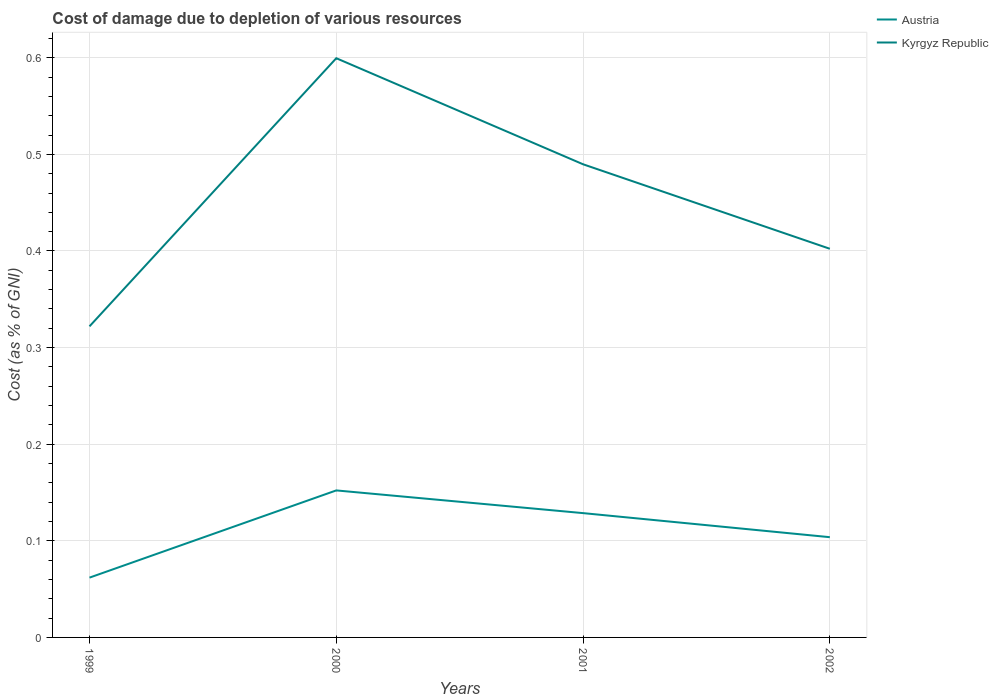Does the line corresponding to Kyrgyz Republic intersect with the line corresponding to Austria?
Your answer should be very brief. No. Is the number of lines equal to the number of legend labels?
Ensure brevity in your answer.  Yes. Across all years, what is the maximum cost of damage caused due to the depletion of various resources in Austria?
Provide a succinct answer. 0.06. What is the total cost of damage caused due to the depletion of various resources in Kyrgyz Republic in the graph?
Your answer should be compact. 0.2. What is the difference between the highest and the second highest cost of damage caused due to the depletion of various resources in Austria?
Give a very brief answer. 0.09. Is the cost of damage caused due to the depletion of various resources in Kyrgyz Republic strictly greater than the cost of damage caused due to the depletion of various resources in Austria over the years?
Give a very brief answer. No. What is the difference between two consecutive major ticks on the Y-axis?
Make the answer very short. 0.1. Does the graph contain grids?
Your answer should be compact. Yes. What is the title of the graph?
Offer a very short reply. Cost of damage due to depletion of various resources. What is the label or title of the X-axis?
Give a very brief answer. Years. What is the label or title of the Y-axis?
Your answer should be compact. Cost (as % of GNI). What is the Cost (as % of GNI) in Austria in 1999?
Provide a succinct answer. 0.06. What is the Cost (as % of GNI) in Kyrgyz Republic in 1999?
Your answer should be very brief. 0.32. What is the Cost (as % of GNI) of Austria in 2000?
Make the answer very short. 0.15. What is the Cost (as % of GNI) in Kyrgyz Republic in 2000?
Ensure brevity in your answer.  0.6. What is the Cost (as % of GNI) of Austria in 2001?
Provide a short and direct response. 0.13. What is the Cost (as % of GNI) of Kyrgyz Republic in 2001?
Make the answer very short. 0.49. What is the Cost (as % of GNI) in Austria in 2002?
Offer a very short reply. 0.1. What is the Cost (as % of GNI) of Kyrgyz Republic in 2002?
Keep it short and to the point. 0.4. Across all years, what is the maximum Cost (as % of GNI) of Austria?
Provide a short and direct response. 0.15. Across all years, what is the maximum Cost (as % of GNI) in Kyrgyz Republic?
Offer a terse response. 0.6. Across all years, what is the minimum Cost (as % of GNI) in Austria?
Offer a terse response. 0.06. Across all years, what is the minimum Cost (as % of GNI) in Kyrgyz Republic?
Your answer should be very brief. 0.32. What is the total Cost (as % of GNI) of Austria in the graph?
Your answer should be very brief. 0.45. What is the total Cost (as % of GNI) in Kyrgyz Republic in the graph?
Give a very brief answer. 1.81. What is the difference between the Cost (as % of GNI) in Austria in 1999 and that in 2000?
Ensure brevity in your answer.  -0.09. What is the difference between the Cost (as % of GNI) of Kyrgyz Republic in 1999 and that in 2000?
Ensure brevity in your answer.  -0.28. What is the difference between the Cost (as % of GNI) in Austria in 1999 and that in 2001?
Give a very brief answer. -0.07. What is the difference between the Cost (as % of GNI) in Kyrgyz Republic in 1999 and that in 2001?
Provide a succinct answer. -0.17. What is the difference between the Cost (as % of GNI) in Austria in 1999 and that in 2002?
Offer a very short reply. -0.04. What is the difference between the Cost (as % of GNI) of Kyrgyz Republic in 1999 and that in 2002?
Your answer should be compact. -0.08. What is the difference between the Cost (as % of GNI) in Austria in 2000 and that in 2001?
Provide a short and direct response. 0.02. What is the difference between the Cost (as % of GNI) in Kyrgyz Republic in 2000 and that in 2001?
Make the answer very short. 0.11. What is the difference between the Cost (as % of GNI) of Austria in 2000 and that in 2002?
Your answer should be very brief. 0.05. What is the difference between the Cost (as % of GNI) of Kyrgyz Republic in 2000 and that in 2002?
Ensure brevity in your answer.  0.2. What is the difference between the Cost (as % of GNI) of Austria in 2001 and that in 2002?
Ensure brevity in your answer.  0.02. What is the difference between the Cost (as % of GNI) of Kyrgyz Republic in 2001 and that in 2002?
Your response must be concise. 0.09. What is the difference between the Cost (as % of GNI) of Austria in 1999 and the Cost (as % of GNI) of Kyrgyz Republic in 2000?
Provide a succinct answer. -0.54. What is the difference between the Cost (as % of GNI) in Austria in 1999 and the Cost (as % of GNI) in Kyrgyz Republic in 2001?
Offer a very short reply. -0.43. What is the difference between the Cost (as % of GNI) in Austria in 1999 and the Cost (as % of GNI) in Kyrgyz Republic in 2002?
Keep it short and to the point. -0.34. What is the difference between the Cost (as % of GNI) in Austria in 2000 and the Cost (as % of GNI) in Kyrgyz Republic in 2001?
Your response must be concise. -0.34. What is the difference between the Cost (as % of GNI) in Austria in 2000 and the Cost (as % of GNI) in Kyrgyz Republic in 2002?
Ensure brevity in your answer.  -0.25. What is the difference between the Cost (as % of GNI) in Austria in 2001 and the Cost (as % of GNI) in Kyrgyz Republic in 2002?
Your response must be concise. -0.27. What is the average Cost (as % of GNI) in Austria per year?
Provide a succinct answer. 0.11. What is the average Cost (as % of GNI) in Kyrgyz Republic per year?
Offer a terse response. 0.45. In the year 1999, what is the difference between the Cost (as % of GNI) of Austria and Cost (as % of GNI) of Kyrgyz Republic?
Provide a succinct answer. -0.26. In the year 2000, what is the difference between the Cost (as % of GNI) in Austria and Cost (as % of GNI) in Kyrgyz Republic?
Ensure brevity in your answer.  -0.45. In the year 2001, what is the difference between the Cost (as % of GNI) of Austria and Cost (as % of GNI) of Kyrgyz Republic?
Provide a short and direct response. -0.36. In the year 2002, what is the difference between the Cost (as % of GNI) of Austria and Cost (as % of GNI) of Kyrgyz Republic?
Your answer should be very brief. -0.3. What is the ratio of the Cost (as % of GNI) of Austria in 1999 to that in 2000?
Provide a short and direct response. 0.41. What is the ratio of the Cost (as % of GNI) in Kyrgyz Republic in 1999 to that in 2000?
Make the answer very short. 0.54. What is the ratio of the Cost (as % of GNI) in Austria in 1999 to that in 2001?
Provide a short and direct response. 0.48. What is the ratio of the Cost (as % of GNI) of Kyrgyz Republic in 1999 to that in 2001?
Provide a succinct answer. 0.66. What is the ratio of the Cost (as % of GNI) in Austria in 1999 to that in 2002?
Offer a very short reply. 0.6. What is the ratio of the Cost (as % of GNI) in Kyrgyz Republic in 1999 to that in 2002?
Make the answer very short. 0.8. What is the ratio of the Cost (as % of GNI) in Austria in 2000 to that in 2001?
Keep it short and to the point. 1.18. What is the ratio of the Cost (as % of GNI) of Kyrgyz Republic in 2000 to that in 2001?
Keep it short and to the point. 1.22. What is the ratio of the Cost (as % of GNI) in Austria in 2000 to that in 2002?
Your response must be concise. 1.47. What is the ratio of the Cost (as % of GNI) in Kyrgyz Republic in 2000 to that in 2002?
Your response must be concise. 1.49. What is the ratio of the Cost (as % of GNI) in Austria in 2001 to that in 2002?
Provide a succinct answer. 1.24. What is the ratio of the Cost (as % of GNI) of Kyrgyz Republic in 2001 to that in 2002?
Your answer should be very brief. 1.22. What is the difference between the highest and the second highest Cost (as % of GNI) of Austria?
Your response must be concise. 0.02. What is the difference between the highest and the second highest Cost (as % of GNI) in Kyrgyz Republic?
Give a very brief answer. 0.11. What is the difference between the highest and the lowest Cost (as % of GNI) of Austria?
Your response must be concise. 0.09. What is the difference between the highest and the lowest Cost (as % of GNI) in Kyrgyz Republic?
Ensure brevity in your answer.  0.28. 